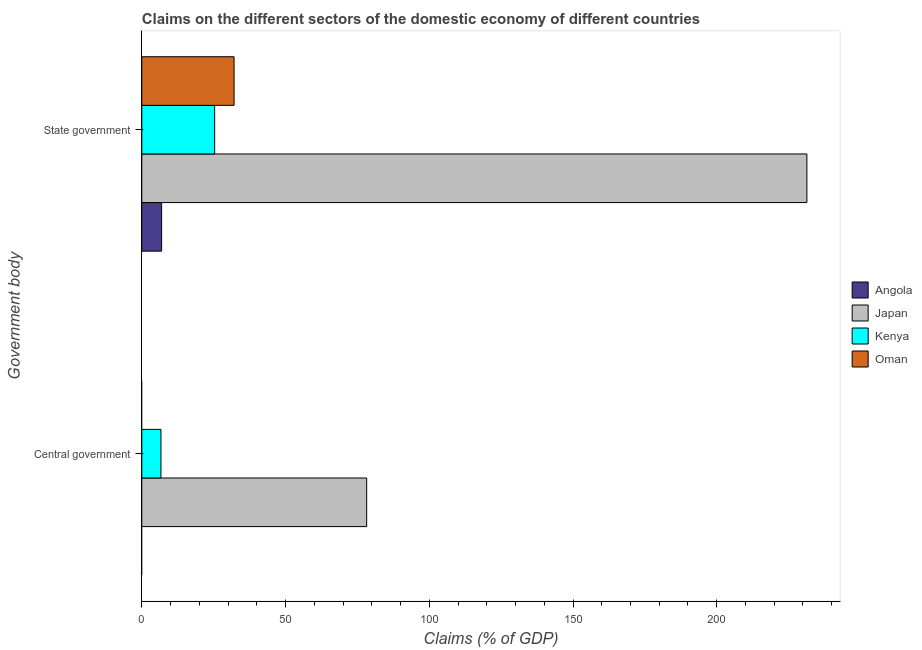Are the number of bars per tick equal to the number of legend labels?
Make the answer very short. No. How many bars are there on the 1st tick from the bottom?
Ensure brevity in your answer.  2. What is the label of the 1st group of bars from the top?
Ensure brevity in your answer.  State government. What is the claims on central government in Oman?
Ensure brevity in your answer.  0. Across all countries, what is the maximum claims on central government?
Your answer should be very brief. 78.23. Across all countries, what is the minimum claims on central government?
Your answer should be very brief. 0. In which country was the claims on state government maximum?
Make the answer very short. Japan. What is the total claims on central government in the graph?
Provide a succinct answer. 84.88. What is the difference between the claims on state government in Oman and that in Kenya?
Make the answer very short. 6.75. What is the difference between the claims on central government in Kenya and the claims on state government in Japan?
Give a very brief answer. -224.71. What is the average claims on central government per country?
Provide a succinct answer. 21.22. What is the difference between the claims on central government and claims on state government in Kenya?
Provide a succinct answer. -18.68. In how many countries, is the claims on state government greater than 210 %?
Ensure brevity in your answer.  1. What is the ratio of the claims on state government in Angola to that in Japan?
Provide a short and direct response. 0.03. How many bars are there?
Offer a terse response. 6. Are all the bars in the graph horizontal?
Ensure brevity in your answer.  Yes. How many countries are there in the graph?
Ensure brevity in your answer.  4. Where does the legend appear in the graph?
Offer a terse response. Center right. How many legend labels are there?
Provide a short and direct response. 4. How are the legend labels stacked?
Your answer should be compact. Vertical. What is the title of the graph?
Your answer should be very brief. Claims on the different sectors of the domestic economy of different countries. What is the label or title of the X-axis?
Provide a short and direct response. Claims (% of GDP). What is the label or title of the Y-axis?
Offer a very short reply. Government body. What is the Claims (% of GDP) of Angola in Central government?
Your response must be concise. 0. What is the Claims (% of GDP) of Japan in Central government?
Make the answer very short. 78.23. What is the Claims (% of GDP) of Kenya in Central government?
Your response must be concise. 6.66. What is the Claims (% of GDP) of Oman in Central government?
Give a very brief answer. 0. What is the Claims (% of GDP) of Angola in State government?
Keep it short and to the point. 6.89. What is the Claims (% of GDP) in Japan in State government?
Your answer should be compact. 231.36. What is the Claims (% of GDP) of Kenya in State government?
Your answer should be very brief. 25.34. What is the Claims (% of GDP) in Oman in State government?
Offer a terse response. 32.1. Across all Government body, what is the maximum Claims (% of GDP) of Angola?
Provide a short and direct response. 6.89. Across all Government body, what is the maximum Claims (% of GDP) in Japan?
Keep it short and to the point. 231.36. Across all Government body, what is the maximum Claims (% of GDP) of Kenya?
Your response must be concise. 25.34. Across all Government body, what is the maximum Claims (% of GDP) of Oman?
Offer a very short reply. 32.1. Across all Government body, what is the minimum Claims (% of GDP) in Japan?
Your response must be concise. 78.23. Across all Government body, what is the minimum Claims (% of GDP) in Kenya?
Your response must be concise. 6.66. Across all Government body, what is the minimum Claims (% of GDP) of Oman?
Ensure brevity in your answer.  0. What is the total Claims (% of GDP) in Angola in the graph?
Offer a terse response. 6.89. What is the total Claims (% of GDP) of Japan in the graph?
Keep it short and to the point. 309.59. What is the total Claims (% of GDP) in Kenya in the graph?
Ensure brevity in your answer.  32. What is the total Claims (% of GDP) of Oman in the graph?
Your answer should be compact. 32.1. What is the difference between the Claims (% of GDP) of Japan in Central government and that in State government?
Your response must be concise. -153.14. What is the difference between the Claims (% of GDP) in Kenya in Central government and that in State government?
Offer a very short reply. -18.68. What is the difference between the Claims (% of GDP) in Japan in Central government and the Claims (% of GDP) in Kenya in State government?
Your response must be concise. 52.88. What is the difference between the Claims (% of GDP) in Japan in Central government and the Claims (% of GDP) in Oman in State government?
Keep it short and to the point. 46.13. What is the difference between the Claims (% of GDP) in Kenya in Central government and the Claims (% of GDP) in Oman in State government?
Ensure brevity in your answer.  -25.44. What is the average Claims (% of GDP) of Angola per Government body?
Your response must be concise. 3.45. What is the average Claims (% of GDP) of Japan per Government body?
Make the answer very short. 154.79. What is the average Claims (% of GDP) of Kenya per Government body?
Keep it short and to the point. 16. What is the average Claims (% of GDP) of Oman per Government body?
Your response must be concise. 16.05. What is the difference between the Claims (% of GDP) of Japan and Claims (% of GDP) of Kenya in Central government?
Your response must be concise. 71.57. What is the difference between the Claims (% of GDP) of Angola and Claims (% of GDP) of Japan in State government?
Your answer should be very brief. -224.47. What is the difference between the Claims (% of GDP) in Angola and Claims (% of GDP) in Kenya in State government?
Make the answer very short. -18.45. What is the difference between the Claims (% of GDP) in Angola and Claims (% of GDP) in Oman in State government?
Ensure brevity in your answer.  -25.2. What is the difference between the Claims (% of GDP) in Japan and Claims (% of GDP) in Kenya in State government?
Ensure brevity in your answer.  206.02. What is the difference between the Claims (% of GDP) of Japan and Claims (% of GDP) of Oman in State government?
Offer a very short reply. 199.27. What is the difference between the Claims (% of GDP) in Kenya and Claims (% of GDP) in Oman in State government?
Your response must be concise. -6.75. What is the ratio of the Claims (% of GDP) of Japan in Central government to that in State government?
Ensure brevity in your answer.  0.34. What is the ratio of the Claims (% of GDP) in Kenya in Central government to that in State government?
Keep it short and to the point. 0.26. What is the difference between the highest and the second highest Claims (% of GDP) of Japan?
Your response must be concise. 153.14. What is the difference between the highest and the second highest Claims (% of GDP) in Kenya?
Make the answer very short. 18.68. What is the difference between the highest and the lowest Claims (% of GDP) of Angola?
Provide a succinct answer. 6.89. What is the difference between the highest and the lowest Claims (% of GDP) in Japan?
Offer a terse response. 153.14. What is the difference between the highest and the lowest Claims (% of GDP) in Kenya?
Provide a short and direct response. 18.68. What is the difference between the highest and the lowest Claims (% of GDP) in Oman?
Offer a terse response. 32.1. 